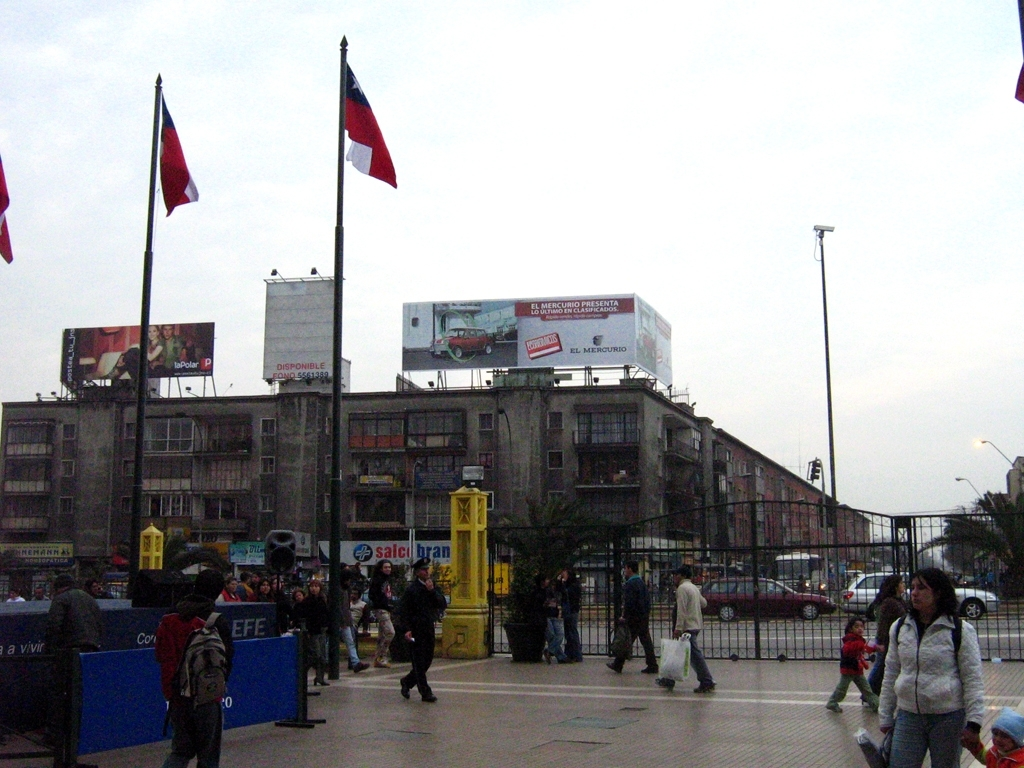Can you describe the weather conditions depicted in the image? The weather in the image appears to be overcast, with a dull sky suggesting it could be a cool or possibly a rainy day. The absence of shadows indicates that the sun is obscured by clouds. The people are dressed in layers, some with jackets, which supports the observation of cooler temperatures. 